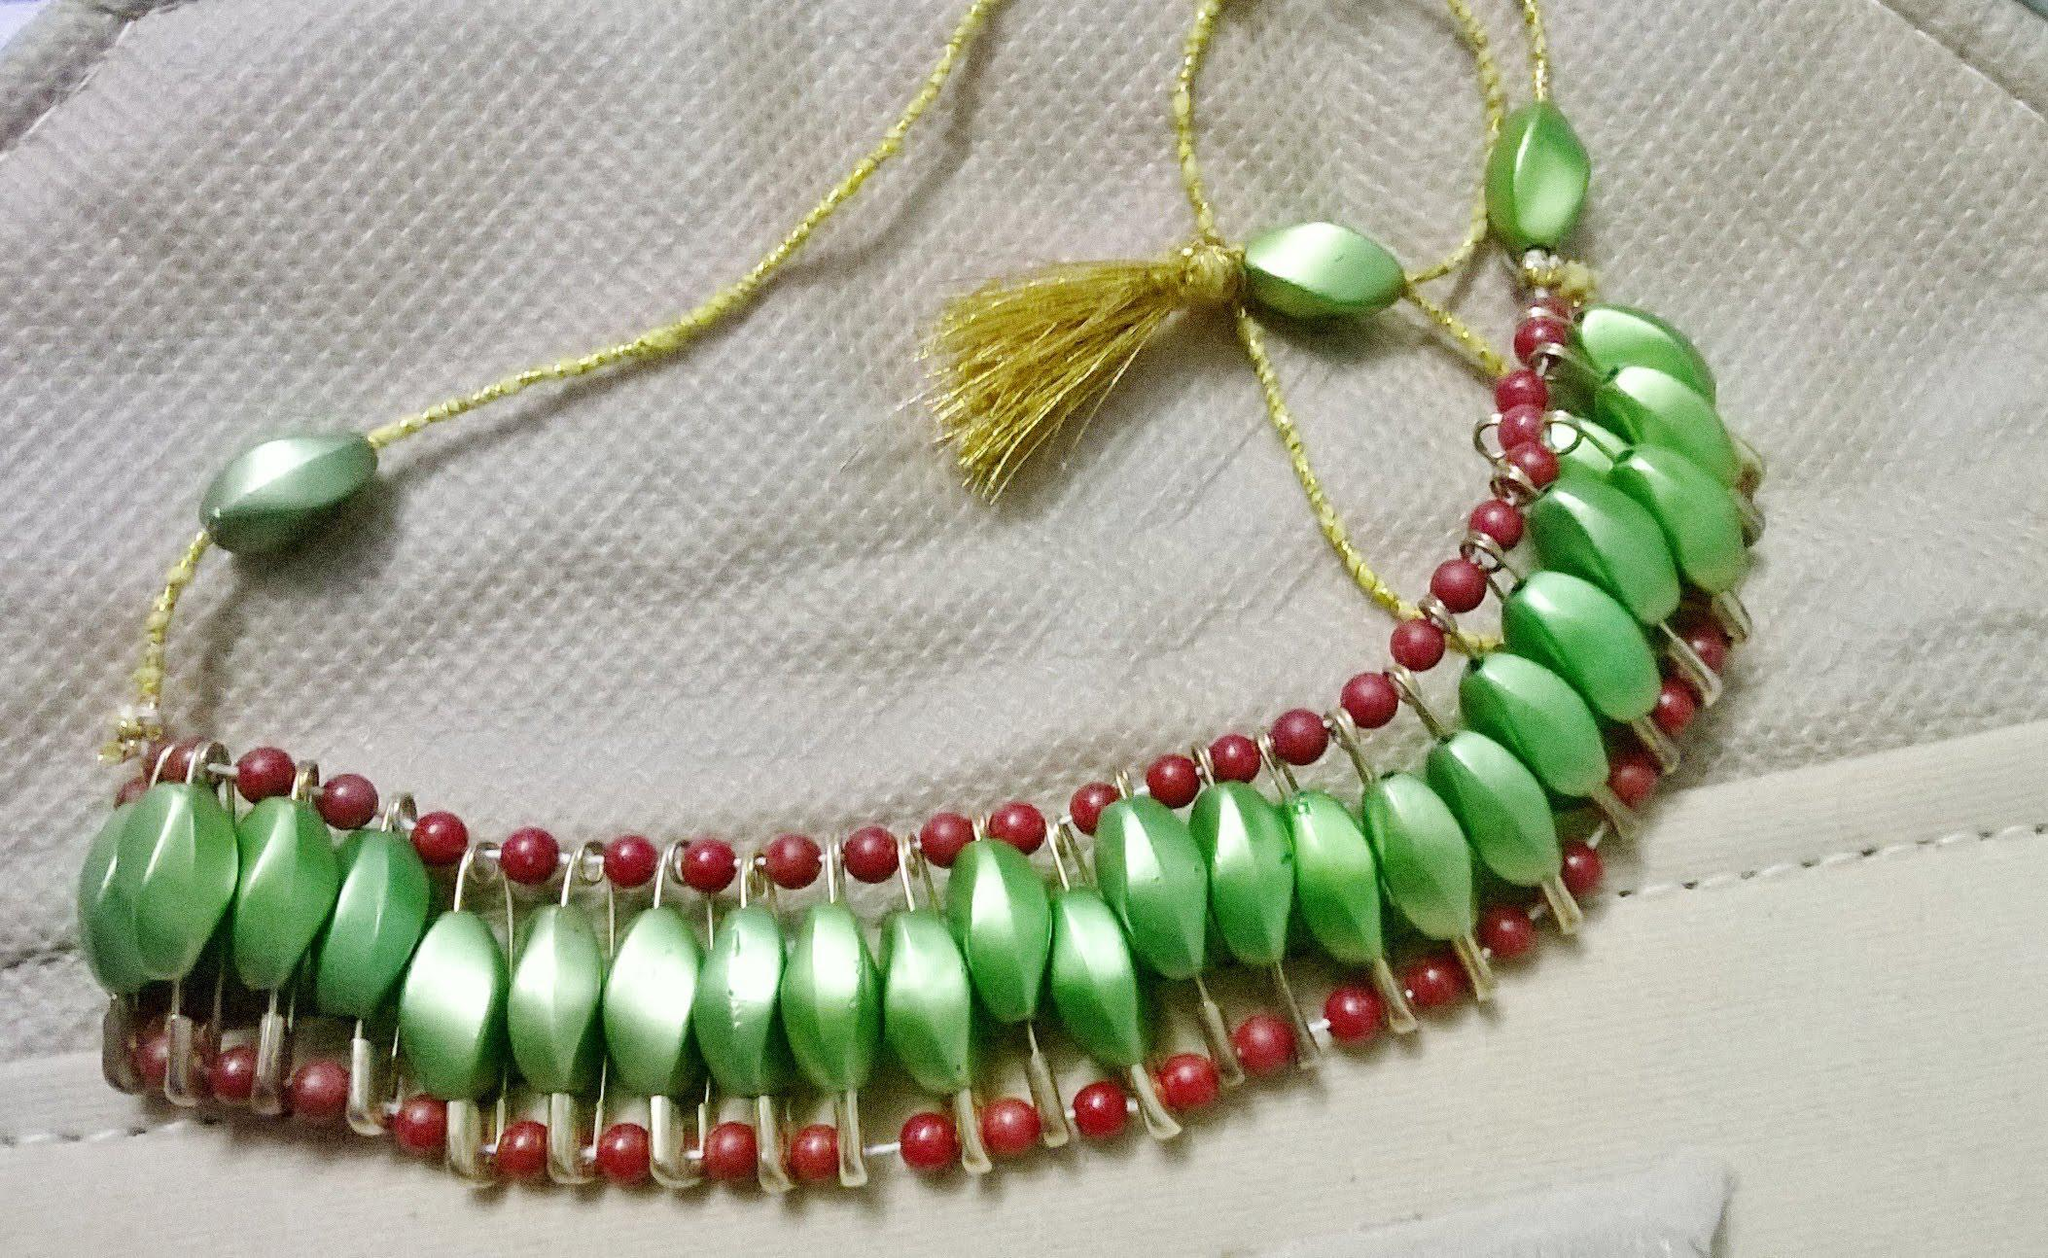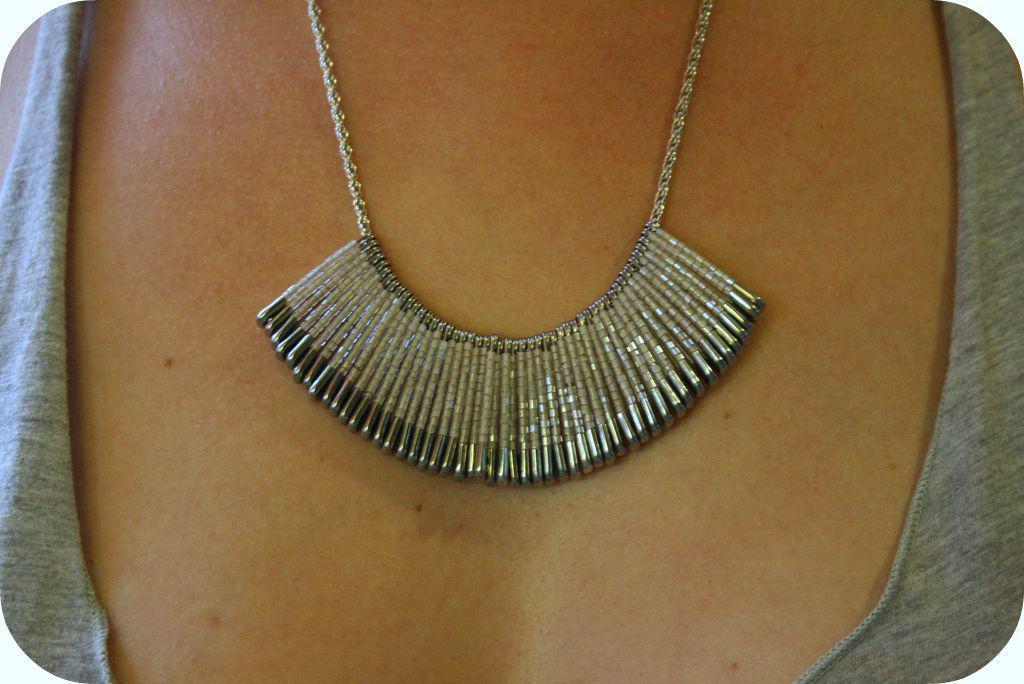The first image is the image on the left, the second image is the image on the right. Given the left and right images, does the statement "one of the images only shows one safety pin." hold true? Answer yes or no. No. 